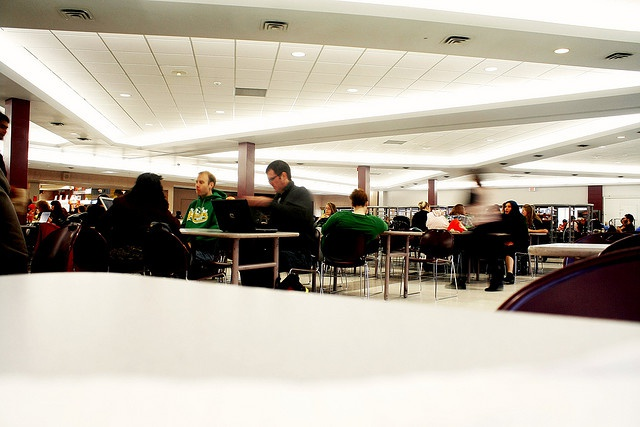Describe the objects in this image and their specific colors. I can see people in gray, black, and maroon tones, people in gray, black, maroon, and brown tones, chair in gray, black, and maroon tones, people in gray, black, darkgreen, maroon, and tan tones, and dining table in gray, black, tan, and darkgreen tones in this image. 